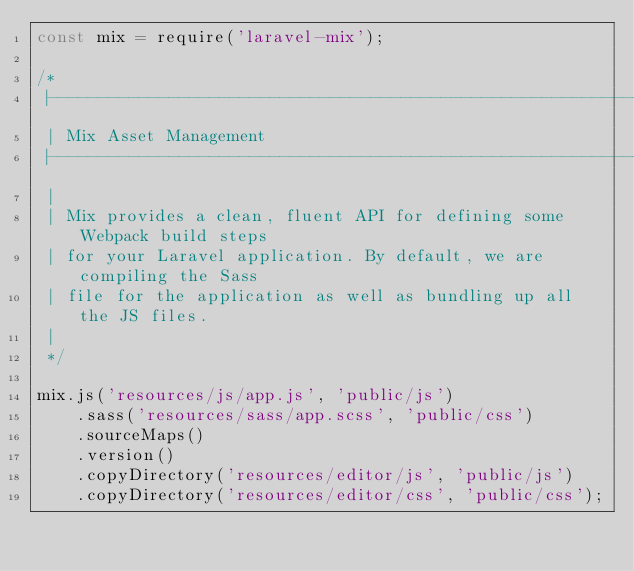<code> <loc_0><loc_0><loc_500><loc_500><_JavaScript_>const mix = require('laravel-mix');

/*
 |--------------------------------------------------------------------------
 | Mix Asset Management
 |--------------------------------------------------------------------------
 |
 | Mix provides a clean, fluent API for defining some Webpack build steps
 | for your Laravel application. By default, we are compiling the Sass
 | file for the application as well as bundling up all the JS files.
 |
 */

mix.js('resources/js/app.js', 'public/js')
    .sass('resources/sass/app.scss', 'public/css')
    .sourceMaps()
    .version()
    .copyDirectory('resources/editor/js', 'public/js')
    .copyDirectory('resources/editor/css', 'public/css');
</code> 